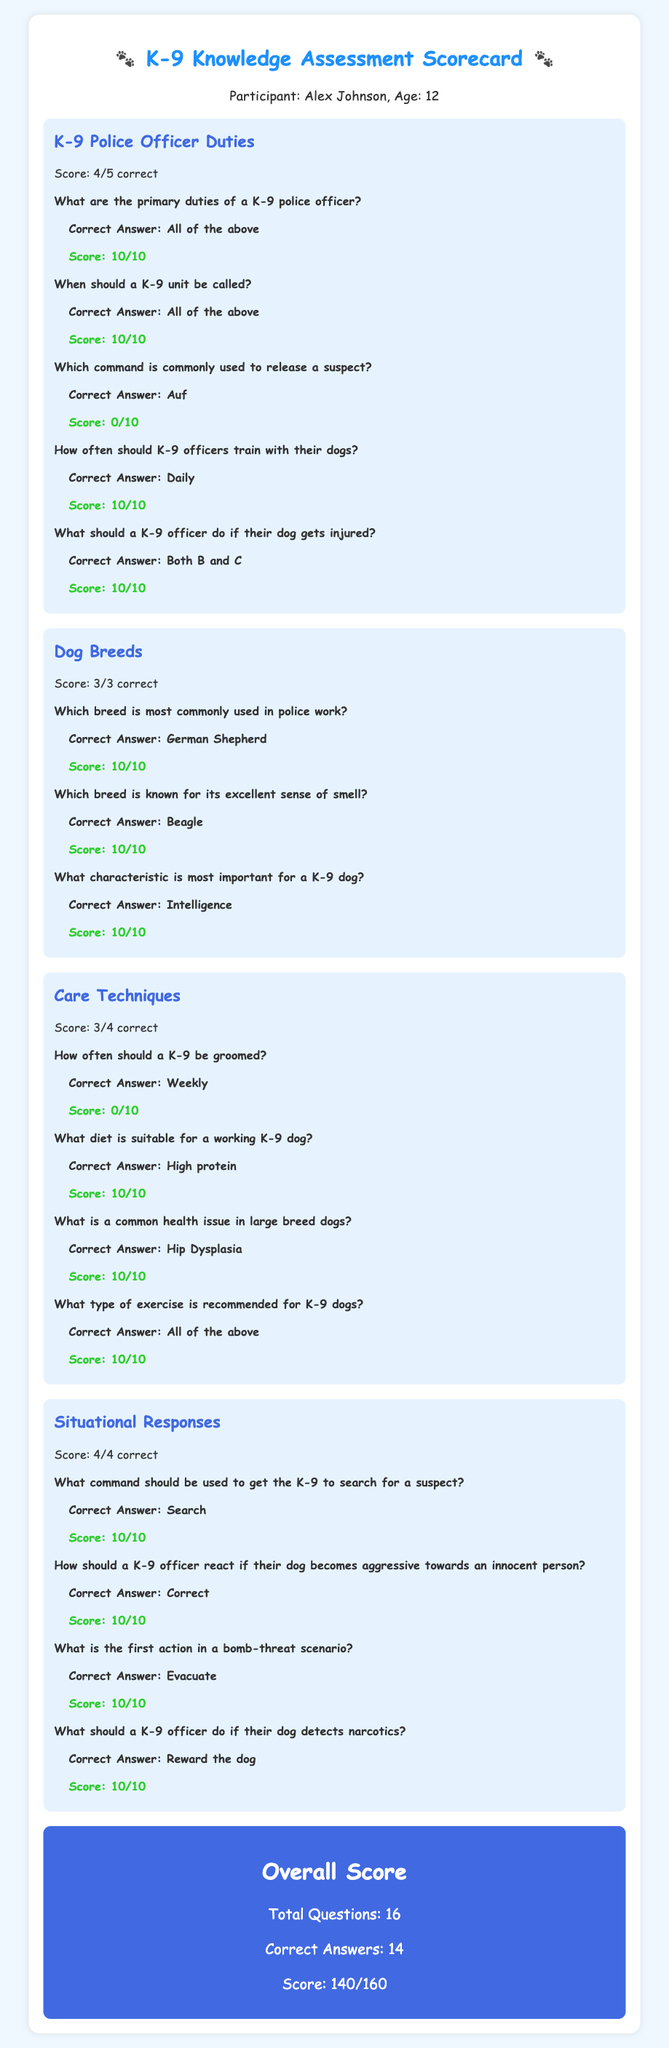What is the name of the participant? The participant's name is shown at the top of the scorecard in the participant information section.
Answer: Alex Johnson How many questions were answered correctly in the K-9 Police Officer Duties category? The score breakdown indicates the number of correct answers in this category.
Answer: 4 What is the score for the Dog Breeds section? Each category has a score displayed, which reflects the number of correct answers.
Answer: 3/3 correct What is the correct answer regarding how often a K-9 should be groomed? The question includes the correct answer listed below it.
Answer: Weekly What is the overall score out of 160? The overall score is a summary provided at the end of the scorecard.
Answer: 140/160 Which command is used for a K-9 to search for a suspect? The document states the specific command associated with this action.
Answer: Search How many total questions were there in the assessment? This information is provided in the overall score section of the document.
Answer: 16 What should a K-9 officer do if their dog detects narcotics? The correct response for this scenario is explicitly mentioned in the situational responses category.
Answer: Reward the dog Which breed is most commonly used in police work? The question refers to the specific dog breed mentioned in the Dog Breeds section.
Answer: German Shepherd 